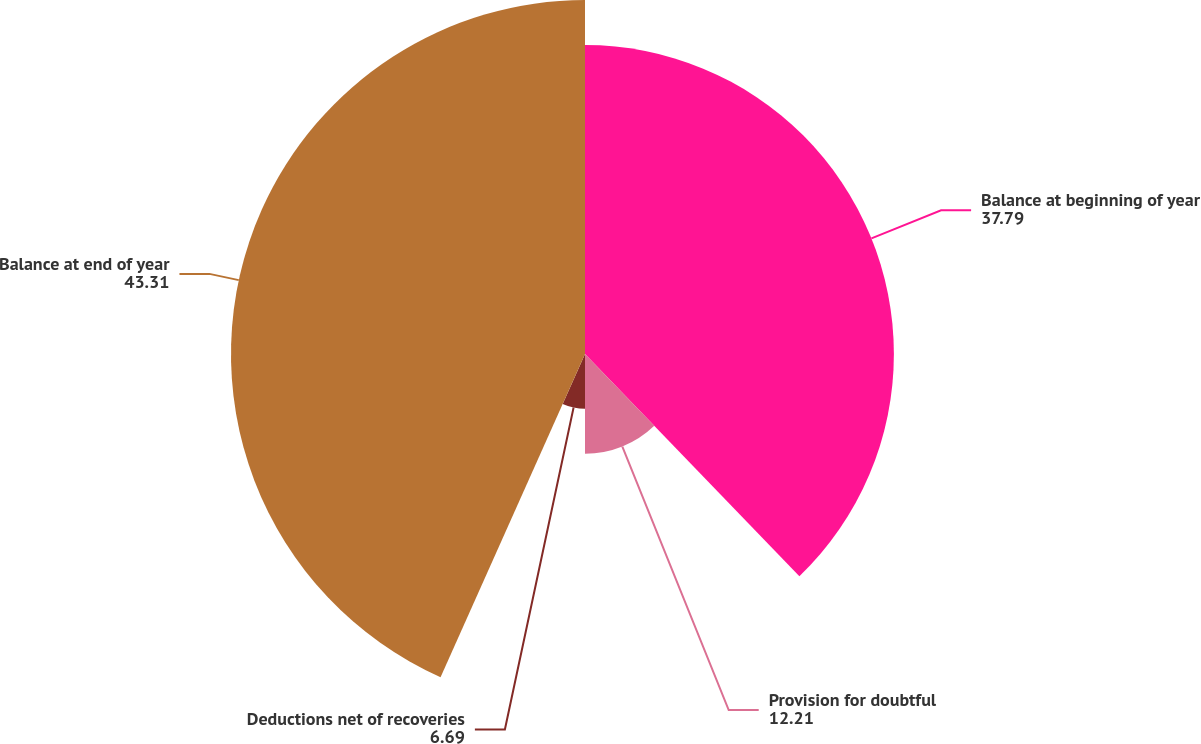<chart> <loc_0><loc_0><loc_500><loc_500><pie_chart><fcel>Balance at beginning of year<fcel>Provision for doubtful<fcel>Deductions net of recoveries<fcel>Balance at end of year<nl><fcel>37.79%<fcel>12.21%<fcel>6.69%<fcel>43.31%<nl></chart> 